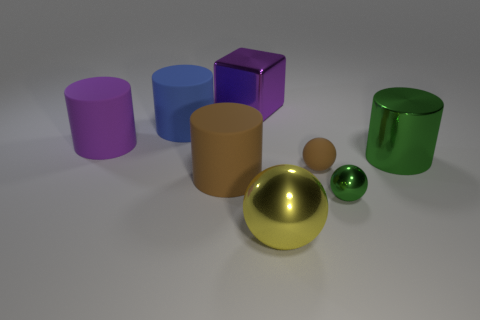Can we estimate the size of these objects relative to each other? Relative sizing can be challenging without reference, but the gold sphere seems largest, followed by the green cylinder. The smallest appears to be the green sphere. These estimations assume they're roughly at the same distance from the viewer. 